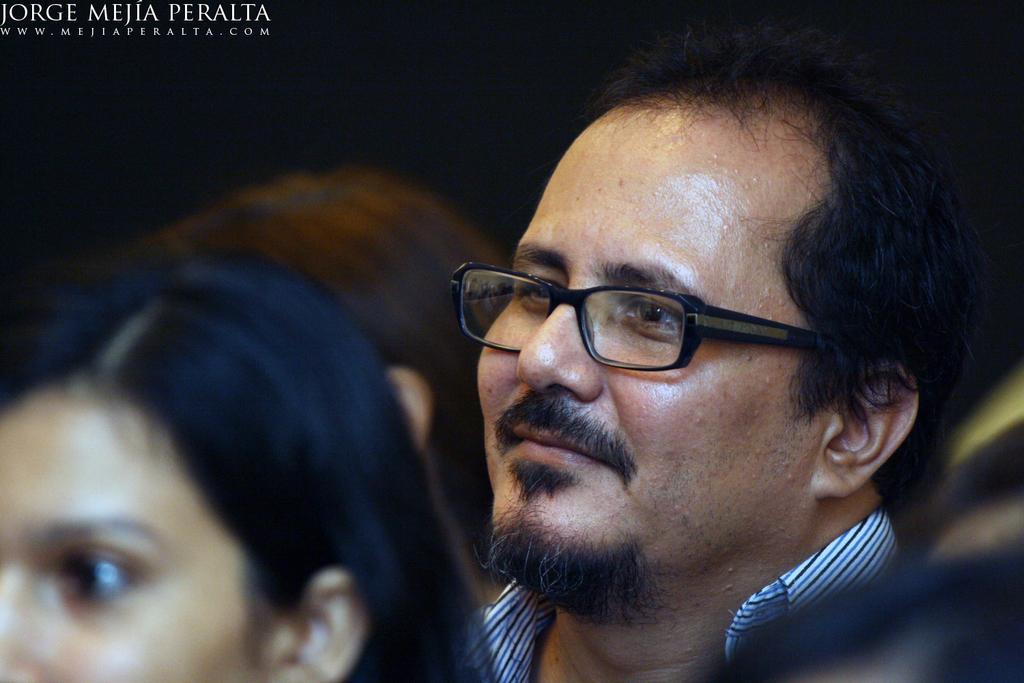How would you summarize this image in a sentence or two? In this picture, we can see a few people, and the dark background, we can see watermark in the top left corner. 